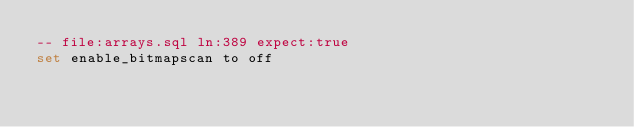<code> <loc_0><loc_0><loc_500><loc_500><_SQL_>-- file:arrays.sql ln:389 expect:true
set enable_bitmapscan to off
</code> 